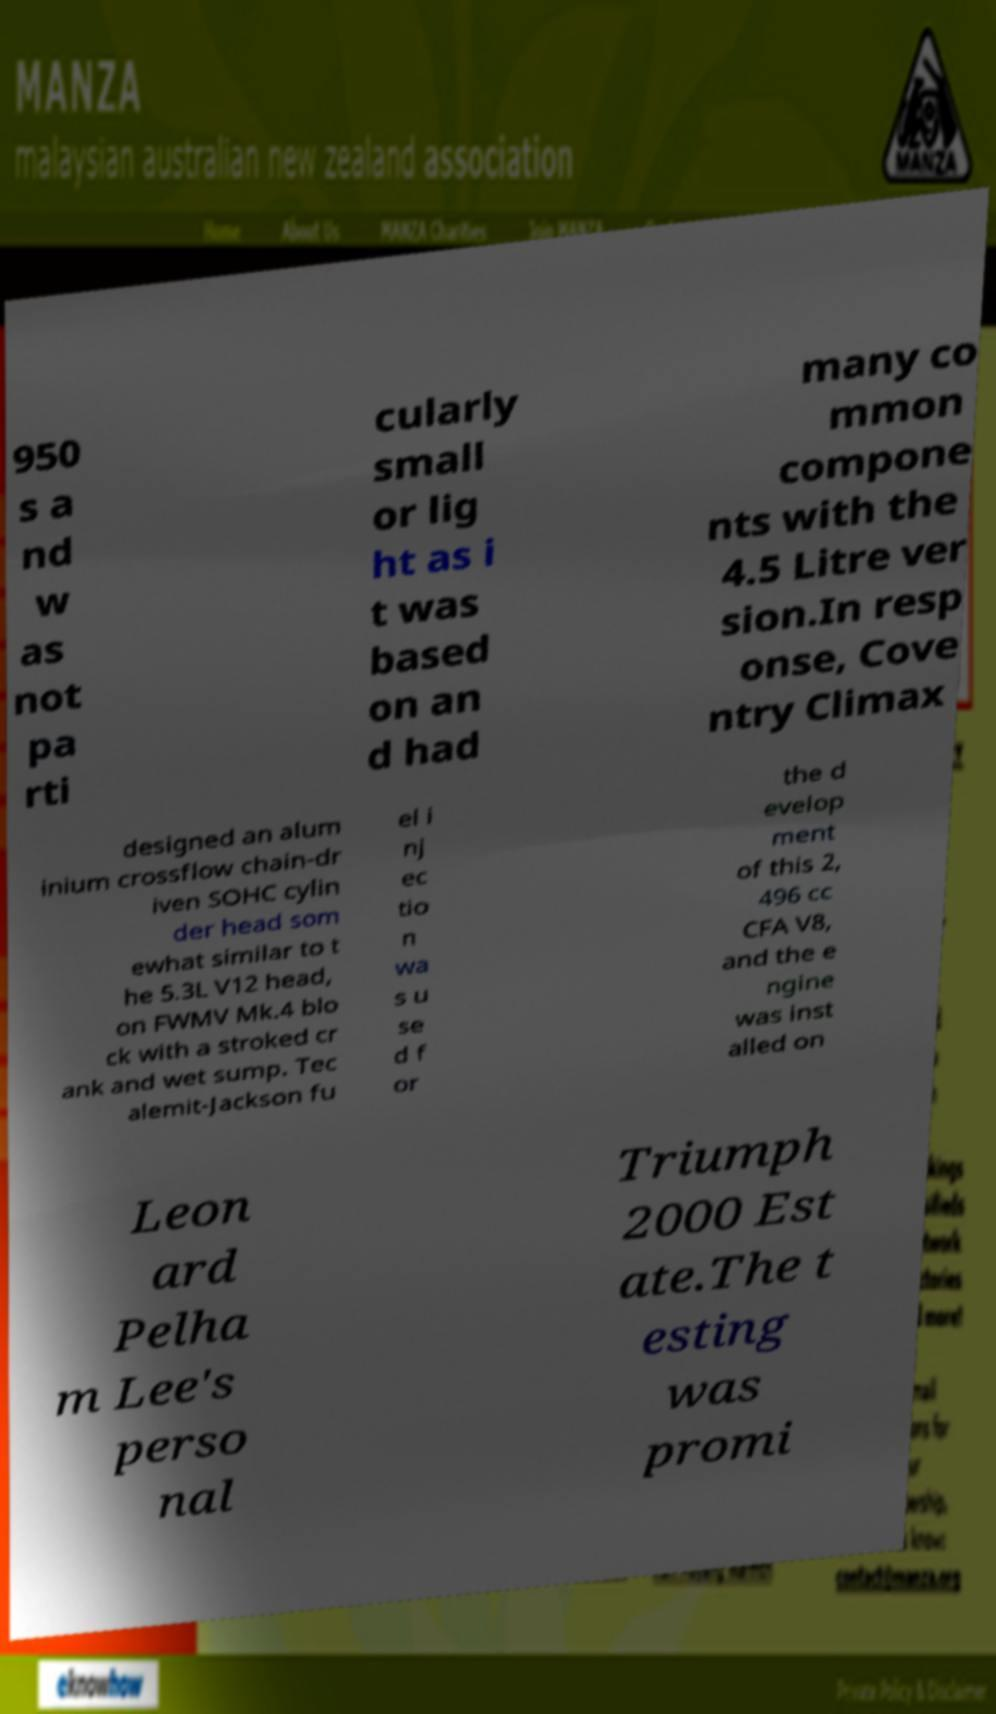Can you read and provide the text displayed in the image?This photo seems to have some interesting text. Can you extract and type it out for me? 950 s a nd w as not pa rti cularly small or lig ht as i t was based on an d had many co mmon compone nts with the 4.5 Litre ver sion.In resp onse, Cove ntry Climax designed an alum inium crossflow chain-dr iven SOHC cylin der head som ewhat similar to t he 5.3L V12 head, on FWMV Mk.4 blo ck with a stroked cr ank and wet sump. Tec alemit-Jackson fu el i nj ec tio n wa s u se d f or the d evelop ment of this 2, 496 cc CFA V8, and the e ngine was inst alled on Leon ard Pelha m Lee's perso nal Triumph 2000 Est ate.The t esting was promi 